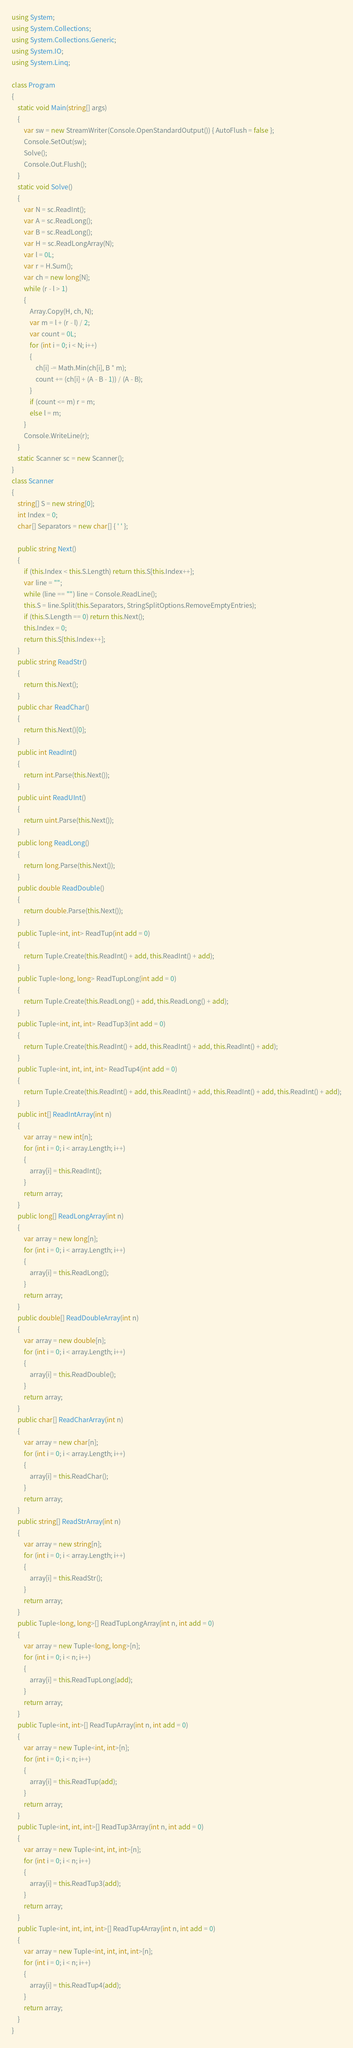<code> <loc_0><loc_0><loc_500><loc_500><_C#_>using System;
using System.Collections;
using System.Collections.Generic;
using System.IO;
using System.Linq;

class Program
{
    static void Main(string[] args)
    {
        var sw = new StreamWriter(Console.OpenStandardOutput()) { AutoFlush = false };
        Console.SetOut(sw);
        Solve();
        Console.Out.Flush();
    }
    static void Solve()
    {
        var N = sc.ReadInt();
        var A = sc.ReadLong();
        var B = sc.ReadLong();
        var H = sc.ReadLongArray(N);
        var l = 0L;
        var r = H.Sum();
        var ch = new long[N];
        while (r - l > 1)
        {
            Array.Copy(H, ch, N);
            var m = l + (r - l) / 2;
            var count = 0L;
            for (int i = 0; i < N; i++)
            {
                ch[i] -= Math.Min(ch[i], B * m);
                count += (ch[i] + (A - B - 1)) / (A - B);
            }
            if (count <= m) r = m;
            else l = m;
        }
        Console.WriteLine(r);
    }
    static Scanner sc = new Scanner();
}
class Scanner
{
    string[] S = new string[0];
    int Index = 0;
    char[] Separators = new char[] { ' ' };

    public string Next()
    {
        if (this.Index < this.S.Length) return this.S[this.Index++];
        var line = "";
        while (line == "") line = Console.ReadLine();
        this.S = line.Split(this.Separators, StringSplitOptions.RemoveEmptyEntries);
        if (this.S.Length == 0) return this.Next();
        this.Index = 0;
        return this.S[this.Index++];
    }
    public string ReadStr()
    {
        return this.Next();
    }
    public char ReadChar()
    {
        return this.Next()[0];
    }
    public int ReadInt()
    {
        return int.Parse(this.Next());
    }
    public uint ReadUInt()
    {
        return uint.Parse(this.Next());
    }
    public long ReadLong()
    {
        return long.Parse(this.Next());
    }
    public double ReadDouble()
    {
        return double.Parse(this.Next());
    }
    public Tuple<int, int> ReadTup(int add = 0)
    {
        return Tuple.Create(this.ReadInt() + add, this.ReadInt() + add);
    }
    public Tuple<long, long> ReadTupLong(int add = 0)
    {
        return Tuple.Create(this.ReadLong() + add, this.ReadLong() + add);
    }
    public Tuple<int, int, int> ReadTup3(int add = 0)
    {
        return Tuple.Create(this.ReadInt() + add, this.ReadInt() + add, this.ReadInt() + add);
    }
    public Tuple<int, int, int, int> ReadTup4(int add = 0)
    {
        return Tuple.Create(this.ReadInt() + add, this.ReadInt() + add, this.ReadInt() + add, this.ReadInt() + add);
    }
    public int[] ReadIntArray(int n)
    {
        var array = new int[n];
        for (int i = 0; i < array.Length; i++)
        {
            array[i] = this.ReadInt();
        }
        return array;
    }
    public long[] ReadLongArray(int n)
    {
        var array = new long[n];
        for (int i = 0; i < array.Length; i++)
        {
            array[i] = this.ReadLong();
        }
        return array;
    }
    public double[] ReadDoubleArray(int n)
    {
        var array = new double[n];
        for (int i = 0; i < array.Length; i++)
        {
            array[i] = this.ReadDouble();
        }
        return array;
    }
    public char[] ReadCharArray(int n)
    {
        var array = new char[n];
        for (int i = 0; i < array.Length; i++)
        {
            array[i] = this.ReadChar();
        }
        return array;
    }
    public string[] ReadStrArray(int n)
    {
        var array = new string[n];
        for (int i = 0; i < array.Length; i++)
        {
            array[i] = this.ReadStr();
        }
        return array;
    }
    public Tuple<long, long>[] ReadTupLongArray(int n, int add = 0)
    {
        var array = new Tuple<long, long>[n];
        for (int i = 0; i < n; i++)
        {
            array[i] = this.ReadTupLong(add);
        }
        return array;
    }
    public Tuple<int, int>[] ReadTupArray(int n, int add = 0)
    {
        var array = new Tuple<int, int>[n];
        for (int i = 0; i < n; i++)
        {
            array[i] = this.ReadTup(add);
        }
        return array;
    }
    public Tuple<int, int, int>[] ReadTup3Array(int n, int add = 0)
    {
        var array = new Tuple<int, int, int>[n];
        for (int i = 0; i < n; i++)
        {
            array[i] = this.ReadTup3(add);
        }
        return array;
    }
    public Tuple<int, int, int, int>[] ReadTup4Array(int n, int add = 0)
    {
        var array = new Tuple<int, int, int, int>[n];
        for (int i = 0; i < n; i++)
        {
            array[i] = this.ReadTup4(add);
        }
        return array;
    }
}
</code> 